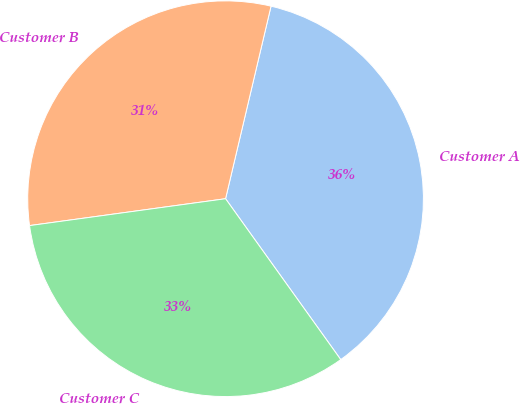Convert chart. <chart><loc_0><loc_0><loc_500><loc_500><pie_chart><fcel>Customer A<fcel>Customer B<fcel>Customer C<nl><fcel>36.42%<fcel>30.86%<fcel>32.72%<nl></chart> 